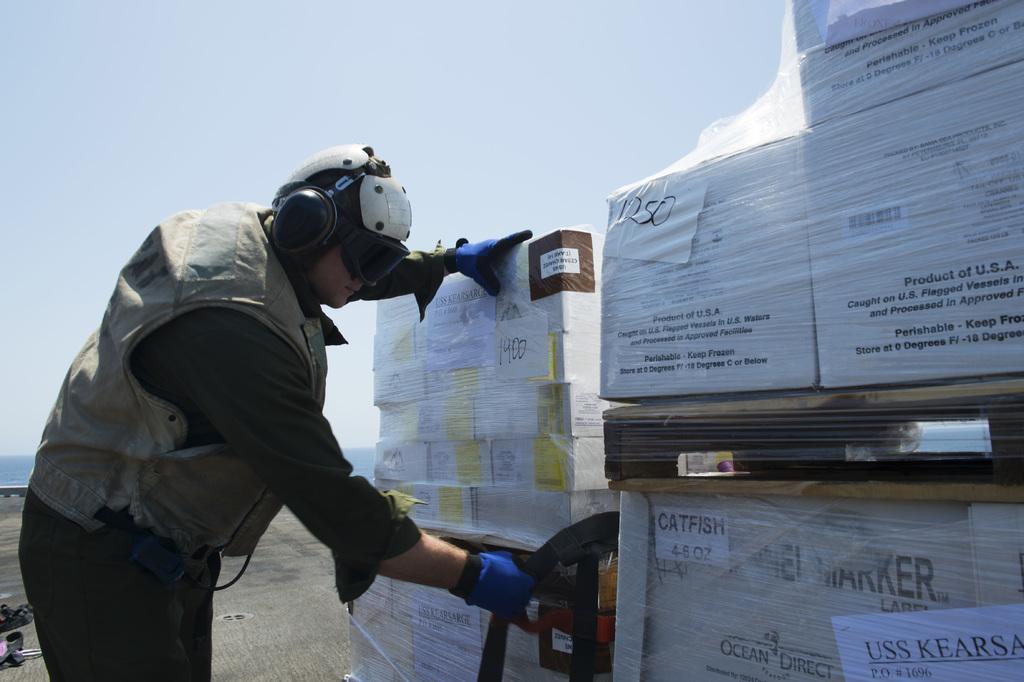Describe this image in one or two sentences. In this picture we can see a man, he wore headphones and spectacles, in front of him we can find few boxes. 